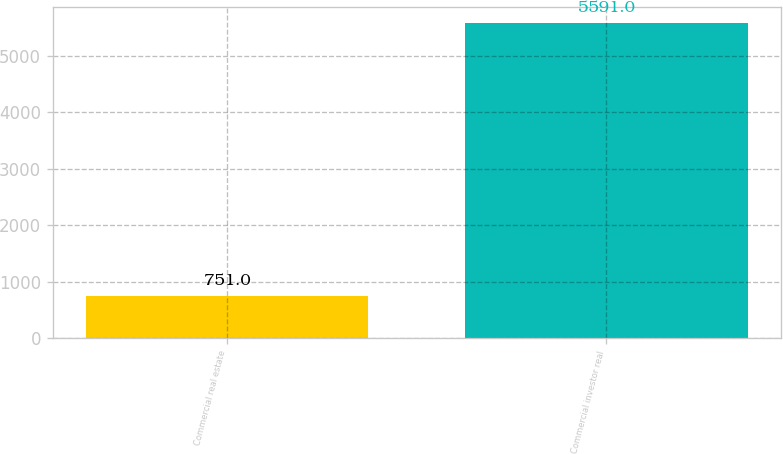Convert chart to OTSL. <chart><loc_0><loc_0><loc_500><loc_500><bar_chart><fcel>Commercial real estate<fcel>Commercial investor real<nl><fcel>751<fcel>5591<nl></chart> 